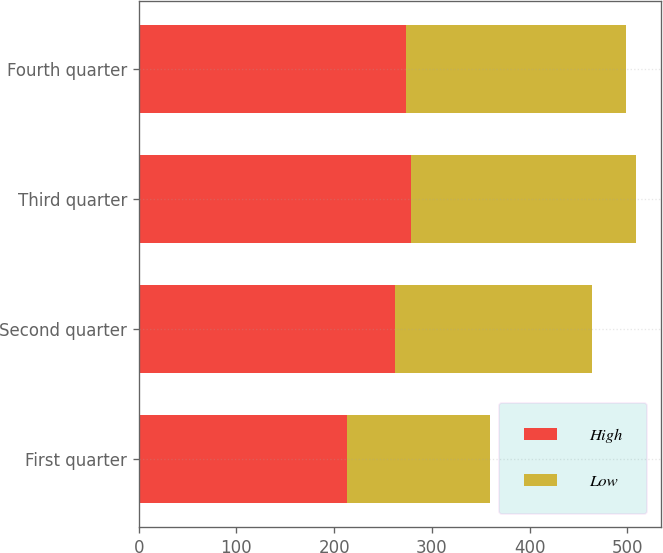<chart> <loc_0><loc_0><loc_500><loc_500><stacked_bar_chart><ecel><fcel>First quarter<fcel>Second quarter<fcel>Third quarter<fcel>Fourth quarter<nl><fcel>High<fcel>212.92<fcel>262.12<fcel>278.63<fcel>273.99<nl><fcel>Low<fcel>146.77<fcel>202.28<fcel>230.1<fcel>225.13<nl></chart> 